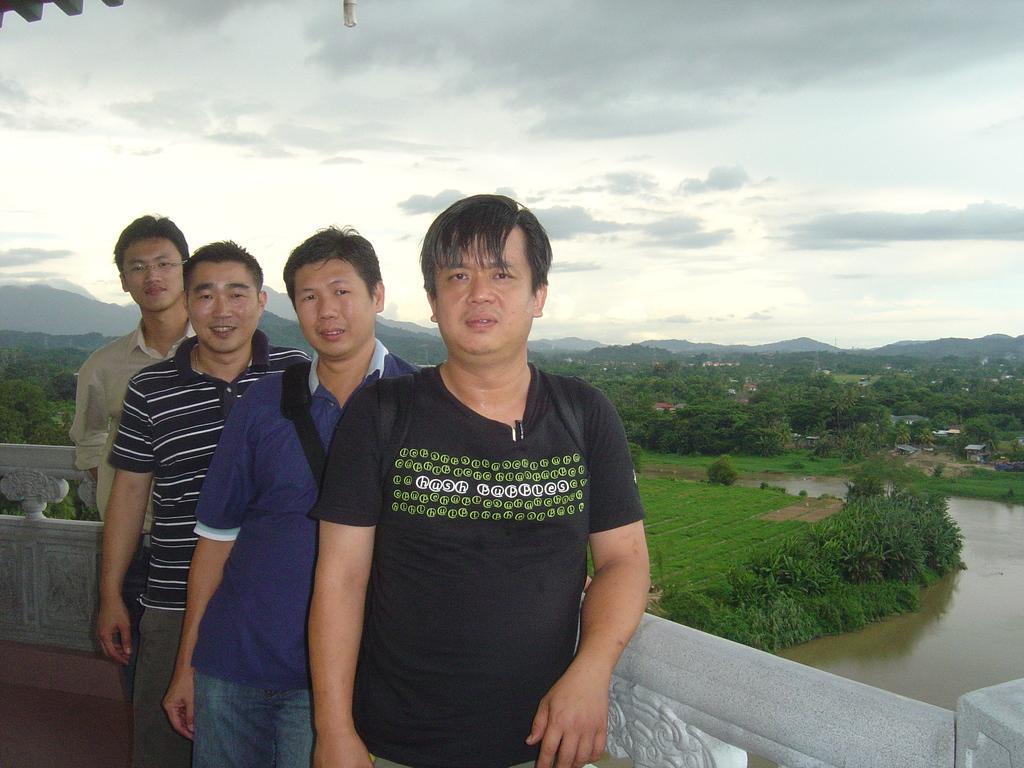Can you describe this image briefly? In this picture I can see four persons standing, there is water, there are buildings, there are trees, hills, and in the background there is the sky. 